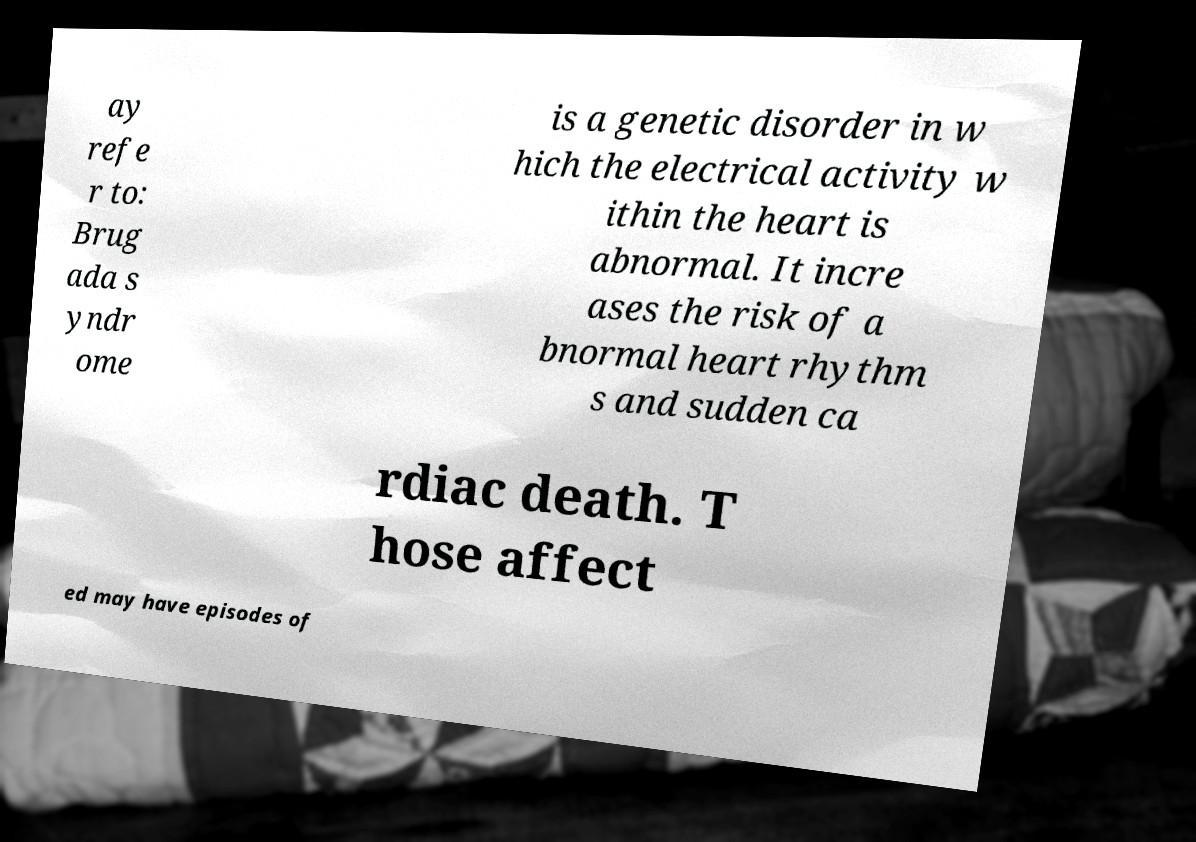Could you extract and type out the text from this image? ay refe r to: Brug ada s yndr ome is a genetic disorder in w hich the electrical activity w ithin the heart is abnormal. It incre ases the risk of a bnormal heart rhythm s and sudden ca rdiac death. T hose affect ed may have episodes of 